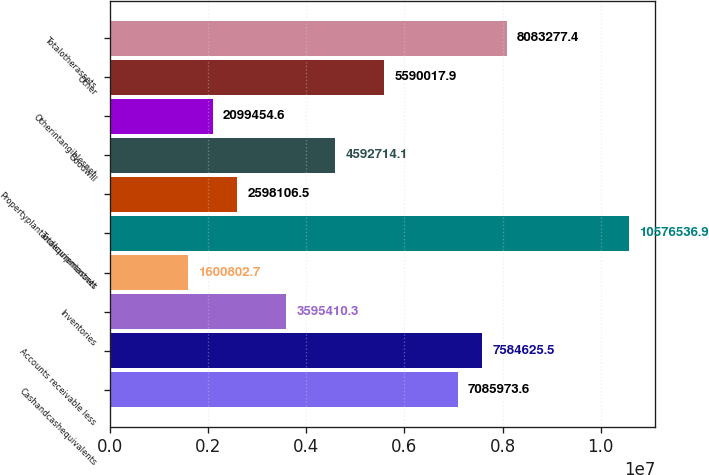Convert chart. <chart><loc_0><loc_0><loc_500><loc_500><bar_chart><fcel>Cashandcashequivalents<fcel>Accounts receivable less<fcel>Inventories<fcel>Unnamed: 3<fcel>Totalcurrentassets<fcel>Propertyplantandequipmentnet<fcel>Goodwill<fcel>Otherintangiblesnet<fcel>Other<fcel>Totalotherassets<nl><fcel>7.08597e+06<fcel>7.58463e+06<fcel>3.59541e+06<fcel>1.6008e+06<fcel>1.05765e+07<fcel>2.59811e+06<fcel>4.59271e+06<fcel>2.09945e+06<fcel>5.59002e+06<fcel>8.08328e+06<nl></chart> 